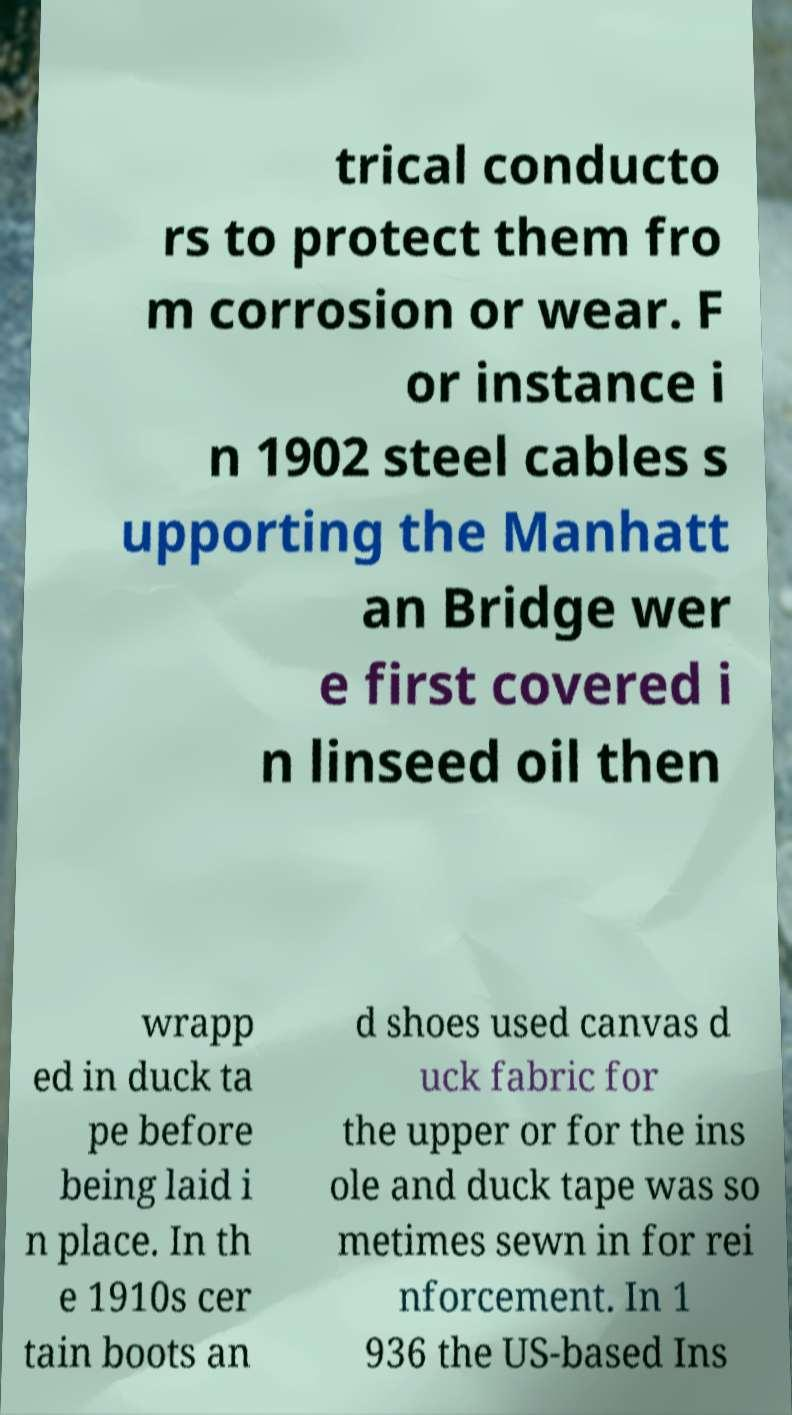Can you read and provide the text displayed in the image?This photo seems to have some interesting text. Can you extract and type it out for me? trical conducto rs to protect them fro m corrosion or wear. F or instance i n 1902 steel cables s upporting the Manhatt an Bridge wer e first covered i n linseed oil then wrapp ed in duck ta pe before being laid i n place. In th e 1910s cer tain boots an d shoes used canvas d uck fabric for the upper or for the ins ole and duck tape was so metimes sewn in for rei nforcement. In 1 936 the US-based Ins 